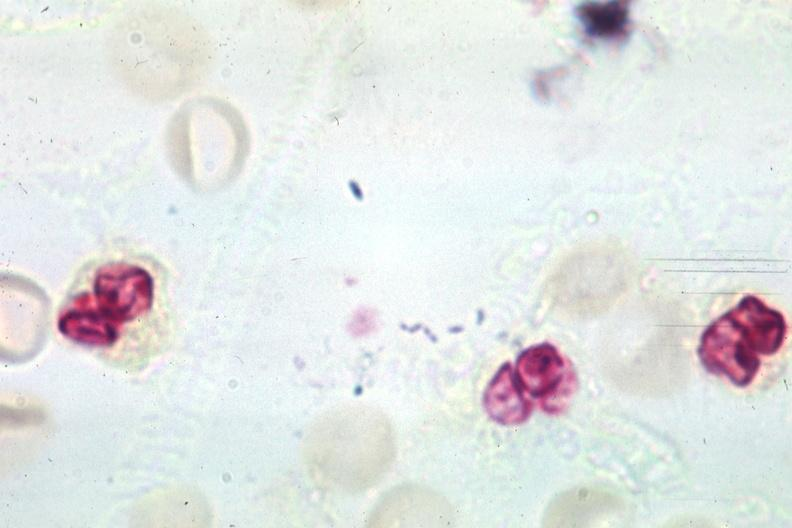s neutrophil gram positive diplococci present?
Answer the question using a single word or phrase. Yes 